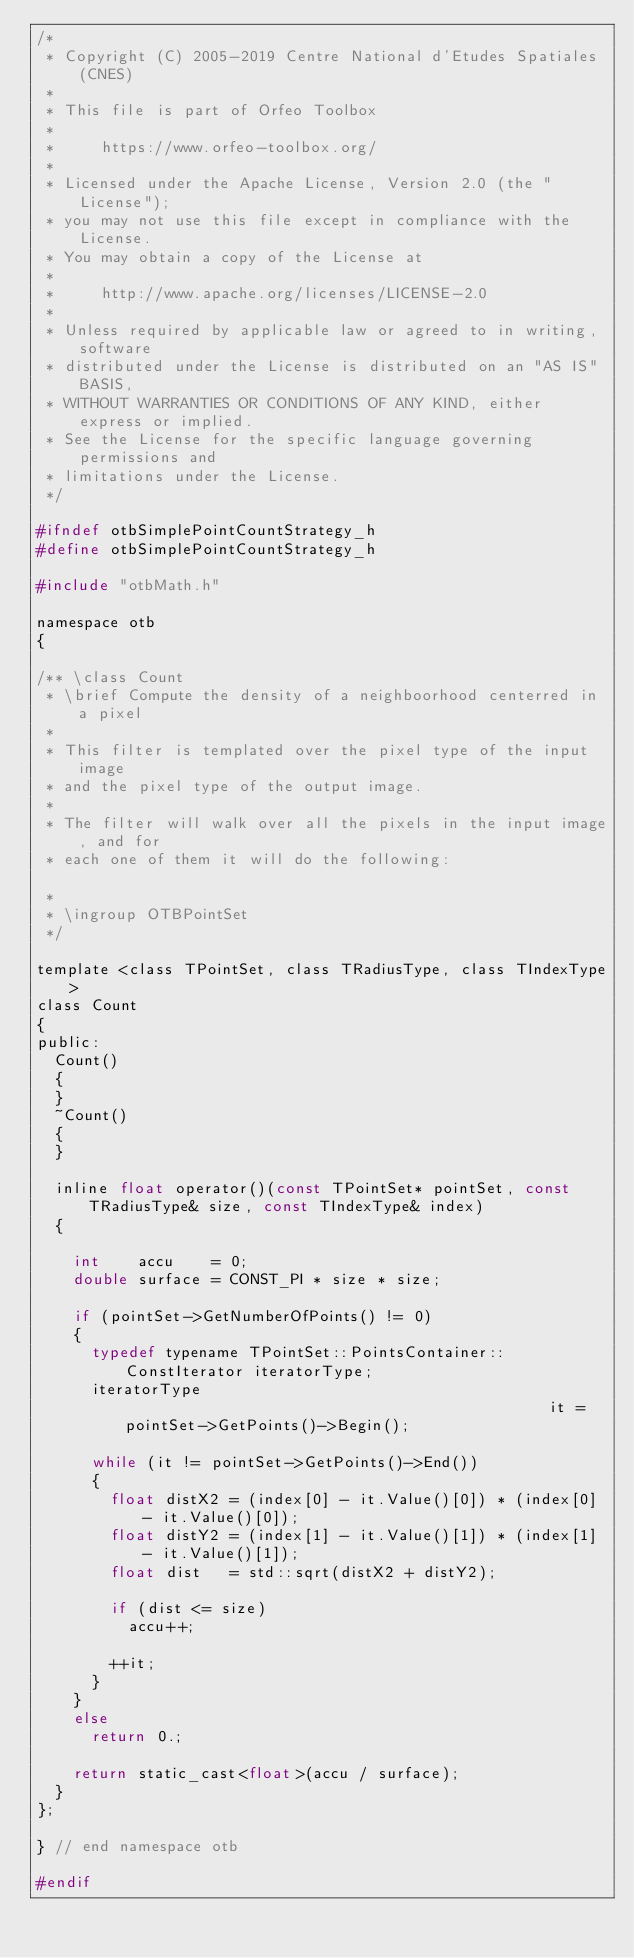Convert code to text. <code><loc_0><loc_0><loc_500><loc_500><_C_>/*
 * Copyright (C) 2005-2019 Centre National d'Etudes Spatiales (CNES)
 *
 * This file is part of Orfeo Toolbox
 *
 *     https://www.orfeo-toolbox.org/
 *
 * Licensed under the Apache License, Version 2.0 (the "License");
 * you may not use this file except in compliance with the License.
 * You may obtain a copy of the License at
 *
 *     http://www.apache.org/licenses/LICENSE-2.0
 *
 * Unless required by applicable law or agreed to in writing, software
 * distributed under the License is distributed on an "AS IS" BASIS,
 * WITHOUT WARRANTIES OR CONDITIONS OF ANY KIND, either express or implied.
 * See the License for the specific language governing permissions and
 * limitations under the License.
 */

#ifndef otbSimplePointCountStrategy_h
#define otbSimplePointCountStrategy_h

#include "otbMath.h"

namespace otb
{

/** \class Count
 * \brief Compute the density of a neighboorhood centerred in a pixel
 *
 * This filter is templated over the pixel type of the input image
 * and the pixel type of the output image.
 *
 * The filter will walk over all the pixels in the input image, and for
 * each one of them it will do the following:

 *
 * \ingroup OTBPointSet
 */

template <class TPointSet, class TRadiusType, class TIndexType>
class Count
{
public:
  Count()
  {
  }
  ~Count()
  {
  }

  inline float operator()(const TPointSet* pointSet, const TRadiusType& size, const TIndexType& index)
  {

    int    accu    = 0;
    double surface = CONST_PI * size * size;

    if (pointSet->GetNumberOfPoints() != 0)
    {
      typedef typename TPointSet::PointsContainer::ConstIterator iteratorType;
      iteratorType                                               it = pointSet->GetPoints()->Begin();

      while (it != pointSet->GetPoints()->End())
      {
        float distX2 = (index[0] - it.Value()[0]) * (index[0] - it.Value()[0]);
        float distY2 = (index[1] - it.Value()[1]) * (index[1] - it.Value()[1]);
        float dist   = std::sqrt(distX2 + distY2);

        if (dist <= size)
          accu++;

        ++it;
      }
    }
    else
      return 0.;

    return static_cast<float>(accu / surface);
  }
};

} // end namespace otb

#endif
</code> 